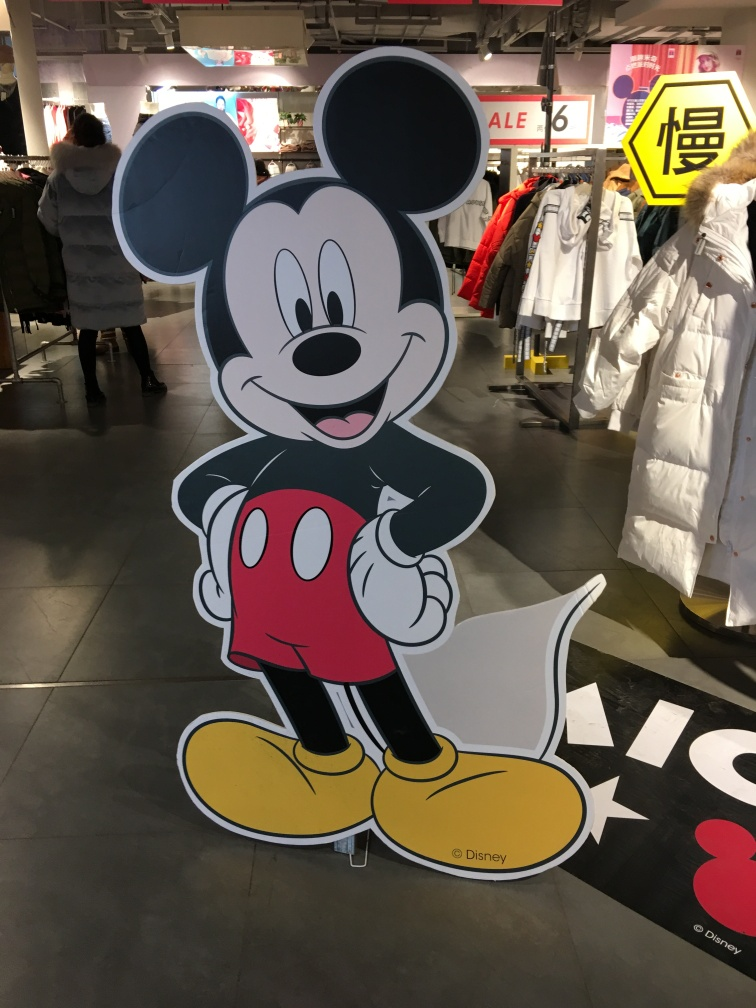What is the composition like?
A. Poor
B. Excellent
C. Unappealing
D. Mediocre The composition presents an iconic and engaging character that is well-centered and fills the frame appropriately. The image is clear, and the character's cheerful expression offers a pleasant visual which could be described as excellent, aligning with option B. 